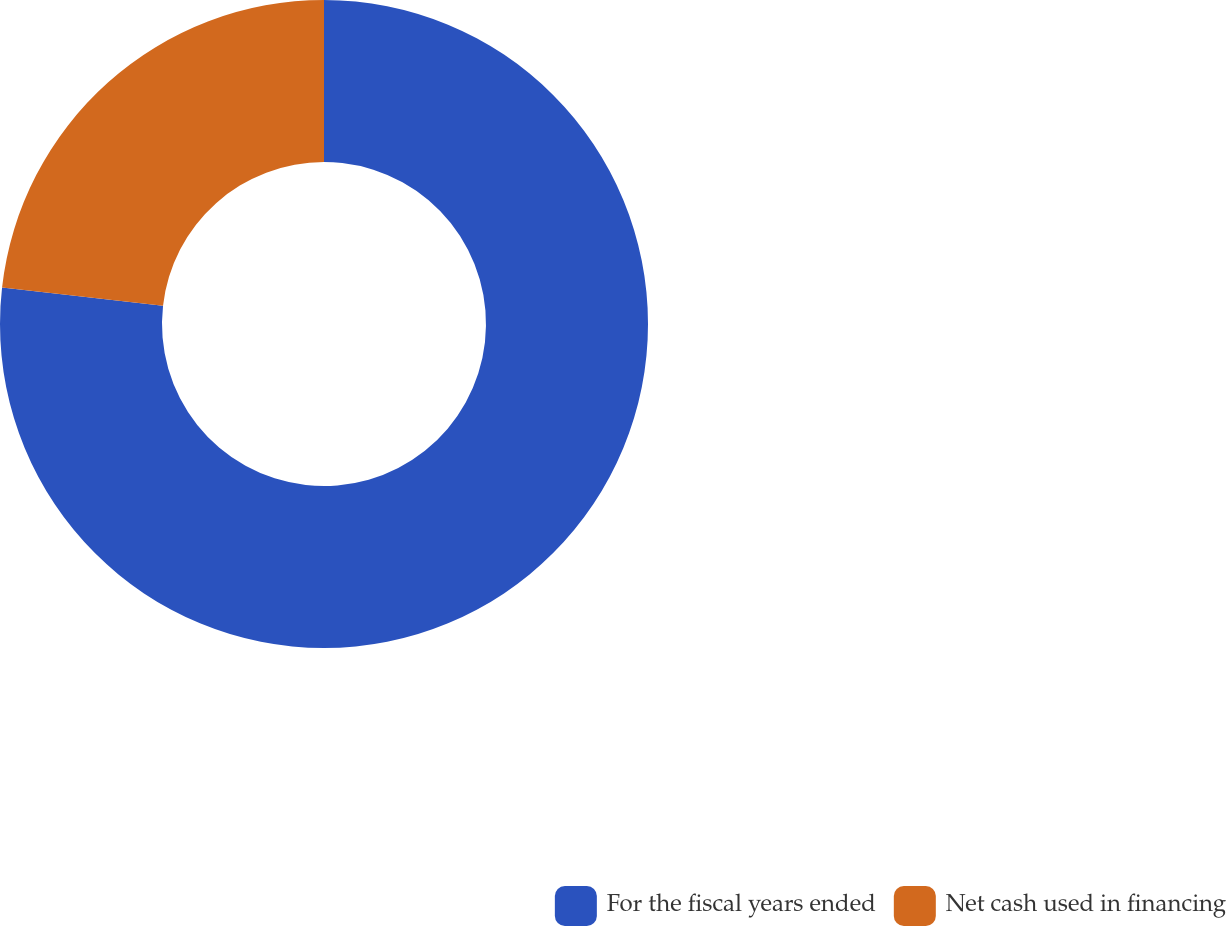<chart> <loc_0><loc_0><loc_500><loc_500><pie_chart><fcel>For the fiscal years ended<fcel>Net cash used in financing<nl><fcel>76.8%<fcel>23.2%<nl></chart> 